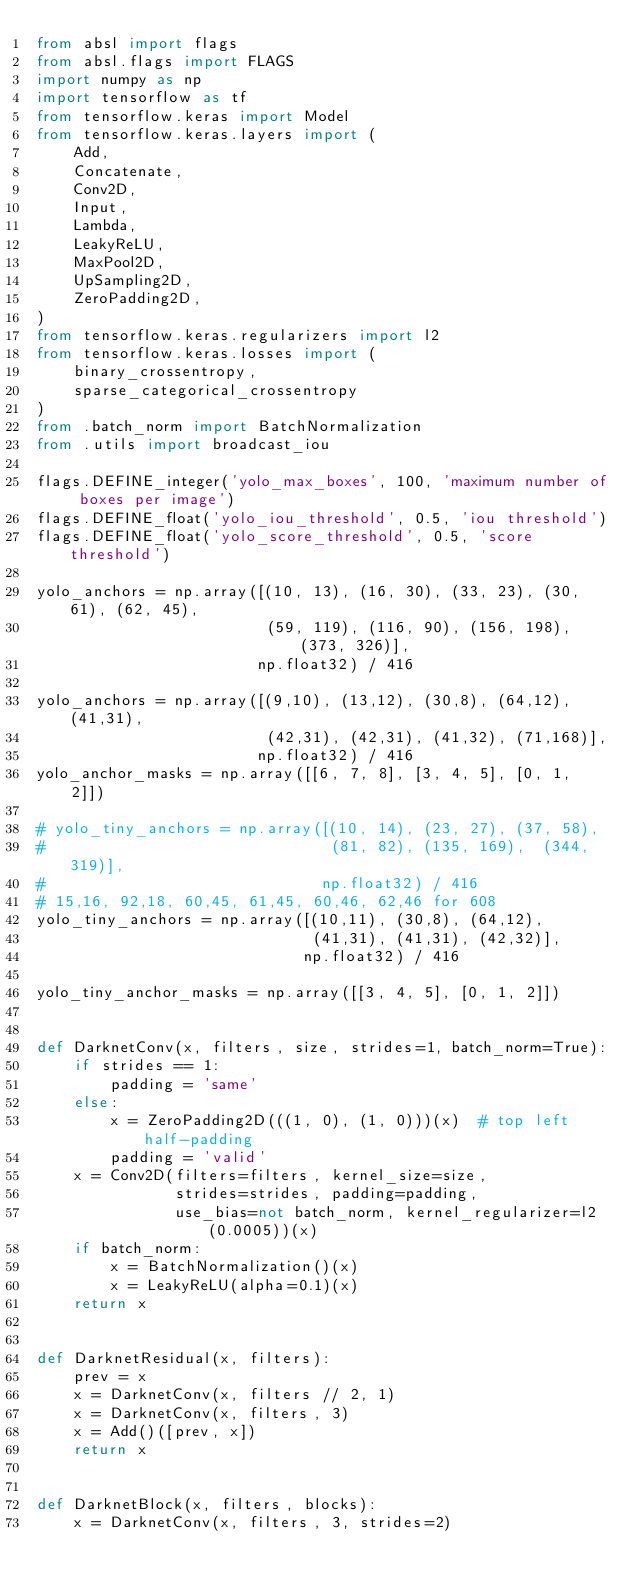Convert code to text. <code><loc_0><loc_0><loc_500><loc_500><_Python_>from absl import flags
from absl.flags import FLAGS
import numpy as np
import tensorflow as tf
from tensorflow.keras import Model
from tensorflow.keras.layers import (
    Add,
    Concatenate,
    Conv2D,
    Input,
    Lambda,
    LeakyReLU,
    MaxPool2D,
    UpSampling2D,
    ZeroPadding2D,
)
from tensorflow.keras.regularizers import l2
from tensorflow.keras.losses import (
    binary_crossentropy,
    sparse_categorical_crossentropy
)
from .batch_norm import BatchNormalization
from .utils import broadcast_iou

flags.DEFINE_integer('yolo_max_boxes', 100, 'maximum number of boxes per image')
flags.DEFINE_float('yolo_iou_threshold', 0.5, 'iou threshold')
flags.DEFINE_float('yolo_score_threshold', 0.5, 'score threshold')

yolo_anchors = np.array([(10, 13), (16, 30), (33, 23), (30, 61), (62, 45),
                         (59, 119), (116, 90), (156, 198), (373, 326)],
                        np.float32) / 416

yolo_anchors = np.array([(9,10), (13,12), (30,8), (64,12), (41,31),
                         (42,31), (42,31), (41,32), (71,168)],
                        np.float32) / 416
yolo_anchor_masks = np.array([[6, 7, 8], [3, 4, 5], [0, 1, 2]])

# yolo_tiny_anchors = np.array([(10, 14), (23, 27), (37, 58),
#                               (81, 82), (135, 169),  (344, 319)],
#                              np.float32) / 416
# 15,16, 92,18, 60,45, 61,45, 60,46, 62,46 for 608
yolo_tiny_anchors = np.array([(10,11), (30,8), (64,12),
                              (41,31), (41,31), (42,32)],
                             np.float32) / 416

yolo_tiny_anchor_masks = np.array([[3, 4, 5], [0, 1, 2]])


def DarknetConv(x, filters, size, strides=1, batch_norm=True):
    if strides == 1:
        padding = 'same'
    else:
        x = ZeroPadding2D(((1, 0), (1, 0)))(x)  # top left half-padding
        padding = 'valid'
    x = Conv2D(filters=filters, kernel_size=size,
               strides=strides, padding=padding,
               use_bias=not batch_norm, kernel_regularizer=l2(0.0005))(x)
    if batch_norm:
        x = BatchNormalization()(x)
        x = LeakyReLU(alpha=0.1)(x)
    return x


def DarknetResidual(x, filters):
    prev = x
    x = DarknetConv(x, filters // 2, 1)
    x = DarknetConv(x, filters, 3)
    x = Add()([prev, x])
    return x


def DarknetBlock(x, filters, blocks):
    x = DarknetConv(x, filters, 3, strides=2)</code> 